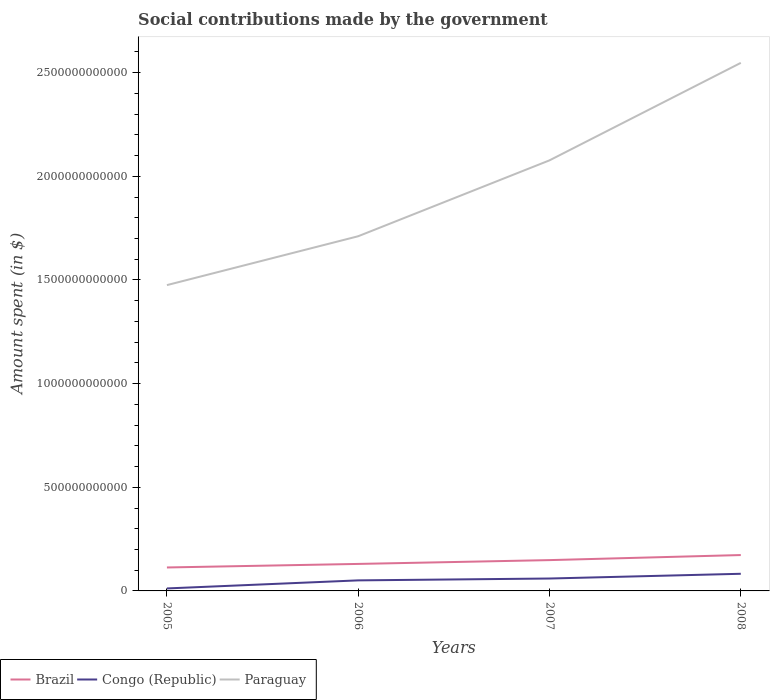Across all years, what is the maximum amount spent on social contributions in Congo (Republic)?
Give a very brief answer. 1.20e+1. What is the total amount spent on social contributions in Congo (Republic) in the graph?
Offer a terse response. -8.97e+09. What is the difference between the highest and the second highest amount spent on social contributions in Brazil?
Provide a short and direct response. 5.99e+1. What is the difference between the highest and the lowest amount spent on social contributions in Brazil?
Your response must be concise. 2. Is the amount spent on social contributions in Congo (Republic) strictly greater than the amount spent on social contributions in Paraguay over the years?
Ensure brevity in your answer.  Yes. How many lines are there?
Provide a succinct answer. 3. What is the difference between two consecutive major ticks on the Y-axis?
Provide a succinct answer. 5.00e+11. Does the graph contain grids?
Ensure brevity in your answer.  No. How many legend labels are there?
Offer a terse response. 3. How are the legend labels stacked?
Offer a very short reply. Horizontal. What is the title of the graph?
Offer a terse response. Social contributions made by the government. What is the label or title of the X-axis?
Make the answer very short. Years. What is the label or title of the Y-axis?
Ensure brevity in your answer.  Amount spent (in $). What is the Amount spent (in $) of Brazil in 2005?
Give a very brief answer. 1.13e+11. What is the Amount spent (in $) in Congo (Republic) in 2005?
Offer a terse response. 1.20e+1. What is the Amount spent (in $) in Paraguay in 2005?
Ensure brevity in your answer.  1.48e+12. What is the Amount spent (in $) of Brazil in 2006?
Ensure brevity in your answer.  1.30e+11. What is the Amount spent (in $) in Congo (Republic) in 2006?
Offer a terse response. 5.09e+1. What is the Amount spent (in $) of Paraguay in 2006?
Ensure brevity in your answer.  1.71e+12. What is the Amount spent (in $) of Brazil in 2007?
Your answer should be compact. 1.49e+11. What is the Amount spent (in $) of Congo (Republic) in 2007?
Keep it short and to the point. 5.99e+1. What is the Amount spent (in $) in Paraguay in 2007?
Give a very brief answer. 2.08e+12. What is the Amount spent (in $) in Brazil in 2008?
Your response must be concise. 1.73e+11. What is the Amount spent (in $) in Congo (Republic) in 2008?
Make the answer very short. 8.27e+1. What is the Amount spent (in $) of Paraguay in 2008?
Offer a very short reply. 2.55e+12. Across all years, what is the maximum Amount spent (in $) in Brazil?
Your answer should be compact. 1.73e+11. Across all years, what is the maximum Amount spent (in $) of Congo (Republic)?
Your response must be concise. 8.27e+1. Across all years, what is the maximum Amount spent (in $) of Paraguay?
Give a very brief answer. 2.55e+12. Across all years, what is the minimum Amount spent (in $) in Brazil?
Make the answer very short. 1.13e+11. Across all years, what is the minimum Amount spent (in $) of Congo (Republic)?
Offer a very short reply. 1.20e+1. Across all years, what is the minimum Amount spent (in $) of Paraguay?
Keep it short and to the point. 1.48e+12. What is the total Amount spent (in $) in Brazil in the graph?
Offer a terse response. 5.65e+11. What is the total Amount spent (in $) of Congo (Republic) in the graph?
Your answer should be compact. 2.05e+11. What is the total Amount spent (in $) in Paraguay in the graph?
Offer a terse response. 7.81e+12. What is the difference between the Amount spent (in $) of Brazil in 2005 and that in 2006?
Provide a short and direct response. -1.71e+1. What is the difference between the Amount spent (in $) in Congo (Republic) in 2005 and that in 2006?
Your response must be concise. -3.89e+1. What is the difference between the Amount spent (in $) of Paraguay in 2005 and that in 2006?
Keep it short and to the point. -2.36e+11. What is the difference between the Amount spent (in $) in Brazil in 2005 and that in 2007?
Keep it short and to the point. -3.55e+1. What is the difference between the Amount spent (in $) of Congo (Republic) in 2005 and that in 2007?
Your answer should be very brief. -4.79e+1. What is the difference between the Amount spent (in $) of Paraguay in 2005 and that in 2007?
Your answer should be very brief. -6.02e+11. What is the difference between the Amount spent (in $) in Brazil in 2005 and that in 2008?
Your response must be concise. -5.99e+1. What is the difference between the Amount spent (in $) in Congo (Republic) in 2005 and that in 2008?
Ensure brevity in your answer.  -7.07e+1. What is the difference between the Amount spent (in $) in Paraguay in 2005 and that in 2008?
Provide a short and direct response. -1.07e+12. What is the difference between the Amount spent (in $) in Brazil in 2006 and that in 2007?
Offer a very short reply. -1.84e+1. What is the difference between the Amount spent (in $) of Congo (Republic) in 2006 and that in 2007?
Your response must be concise. -8.97e+09. What is the difference between the Amount spent (in $) in Paraguay in 2006 and that in 2007?
Provide a succinct answer. -3.66e+11. What is the difference between the Amount spent (in $) of Brazil in 2006 and that in 2008?
Give a very brief answer. -4.28e+1. What is the difference between the Amount spent (in $) in Congo (Republic) in 2006 and that in 2008?
Offer a terse response. -3.18e+1. What is the difference between the Amount spent (in $) of Paraguay in 2006 and that in 2008?
Offer a very short reply. -8.36e+11. What is the difference between the Amount spent (in $) in Brazil in 2007 and that in 2008?
Offer a terse response. -2.44e+1. What is the difference between the Amount spent (in $) of Congo (Republic) in 2007 and that in 2008?
Keep it short and to the point. -2.28e+1. What is the difference between the Amount spent (in $) of Paraguay in 2007 and that in 2008?
Give a very brief answer. -4.70e+11. What is the difference between the Amount spent (in $) in Brazil in 2005 and the Amount spent (in $) in Congo (Republic) in 2006?
Keep it short and to the point. 6.23e+1. What is the difference between the Amount spent (in $) of Brazil in 2005 and the Amount spent (in $) of Paraguay in 2006?
Your answer should be compact. -1.60e+12. What is the difference between the Amount spent (in $) in Congo (Republic) in 2005 and the Amount spent (in $) in Paraguay in 2006?
Your answer should be very brief. -1.70e+12. What is the difference between the Amount spent (in $) of Brazil in 2005 and the Amount spent (in $) of Congo (Republic) in 2007?
Give a very brief answer. 5.33e+1. What is the difference between the Amount spent (in $) in Brazil in 2005 and the Amount spent (in $) in Paraguay in 2007?
Offer a very short reply. -1.96e+12. What is the difference between the Amount spent (in $) of Congo (Republic) in 2005 and the Amount spent (in $) of Paraguay in 2007?
Offer a very short reply. -2.07e+12. What is the difference between the Amount spent (in $) of Brazil in 2005 and the Amount spent (in $) of Congo (Republic) in 2008?
Make the answer very short. 3.04e+1. What is the difference between the Amount spent (in $) of Brazil in 2005 and the Amount spent (in $) of Paraguay in 2008?
Your answer should be very brief. -2.43e+12. What is the difference between the Amount spent (in $) in Congo (Republic) in 2005 and the Amount spent (in $) in Paraguay in 2008?
Offer a terse response. -2.54e+12. What is the difference between the Amount spent (in $) in Brazil in 2006 and the Amount spent (in $) in Congo (Republic) in 2007?
Provide a succinct answer. 7.04e+1. What is the difference between the Amount spent (in $) in Brazil in 2006 and the Amount spent (in $) in Paraguay in 2007?
Your answer should be very brief. -1.95e+12. What is the difference between the Amount spent (in $) of Congo (Republic) in 2006 and the Amount spent (in $) of Paraguay in 2007?
Offer a terse response. -2.03e+12. What is the difference between the Amount spent (in $) in Brazil in 2006 and the Amount spent (in $) in Congo (Republic) in 2008?
Ensure brevity in your answer.  4.76e+1. What is the difference between the Amount spent (in $) in Brazil in 2006 and the Amount spent (in $) in Paraguay in 2008?
Ensure brevity in your answer.  -2.42e+12. What is the difference between the Amount spent (in $) of Congo (Republic) in 2006 and the Amount spent (in $) of Paraguay in 2008?
Provide a succinct answer. -2.50e+12. What is the difference between the Amount spent (in $) in Brazil in 2007 and the Amount spent (in $) in Congo (Republic) in 2008?
Your response must be concise. 6.59e+1. What is the difference between the Amount spent (in $) of Brazil in 2007 and the Amount spent (in $) of Paraguay in 2008?
Offer a very short reply. -2.40e+12. What is the difference between the Amount spent (in $) of Congo (Republic) in 2007 and the Amount spent (in $) of Paraguay in 2008?
Your answer should be very brief. -2.49e+12. What is the average Amount spent (in $) of Brazil per year?
Offer a very short reply. 1.41e+11. What is the average Amount spent (in $) of Congo (Republic) per year?
Keep it short and to the point. 5.14e+1. What is the average Amount spent (in $) of Paraguay per year?
Your answer should be compact. 1.95e+12. In the year 2005, what is the difference between the Amount spent (in $) of Brazil and Amount spent (in $) of Congo (Republic)?
Give a very brief answer. 1.01e+11. In the year 2005, what is the difference between the Amount spent (in $) of Brazil and Amount spent (in $) of Paraguay?
Offer a terse response. -1.36e+12. In the year 2005, what is the difference between the Amount spent (in $) in Congo (Republic) and Amount spent (in $) in Paraguay?
Provide a succinct answer. -1.46e+12. In the year 2006, what is the difference between the Amount spent (in $) of Brazil and Amount spent (in $) of Congo (Republic)?
Offer a very short reply. 7.94e+1. In the year 2006, what is the difference between the Amount spent (in $) of Brazil and Amount spent (in $) of Paraguay?
Your answer should be compact. -1.58e+12. In the year 2006, what is the difference between the Amount spent (in $) in Congo (Republic) and Amount spent (in $) in Paraguay?
Your answer should be compact. -1.66e+12. In the year 2007, what is the difference between the Amount spent (in $) of Brazil and Amount spent (in $) of Congo (Republic)?
Give a very brief answer. 8.88e+1. In the year 2007, what is the difference between the Amount spent (in $) of Brazil and Amount spent (in $) of Paraguay?
Make the answer very short. -1.93e+12. In the year 2007, what is the difference between the Amount spent (in $) of Congo (Republic) and Amount spent (in $) of Paraguay?
Your answer should be very brief. -2.02e+12. In the year 2008, what is the difference between the Amount spent (in $) in Brazil and Amount spent (in $) in Congo (Republic)?
Keep it short and to the point. 9.03e+1. In the year 2008, what is the difference between the Amount spent (in $) in Brazil and Amount spent (in $) in Paraguay?
Provide a succinct answer. -2.37e+12. In the year 2008, what is the difference between the Amount spent (in $) in Congo (Republic) and Amount spent (in $) in Paraguay?
Your answer should be very brief. -2.46e+12. What is the ratio of the Amount spent (in $) of Brazil in 2005 to that in 2006?
Provide a succinct answer. 0.87. What is the ratio of the Amount spent (in $) of Congo (Republic) in 2005 to that in 2006?
Make the answer very short. 0.24. What is the ratio of the Amount spent (in $) in Paraguay in 2005 to that in 2006?
Provide a short and direct response. 0.86. What is the ratio of the Amount spent (in $) in Brazil in 2005 to that in 2007?
Offer a very short reply. 0.76. What is the ratio of the Amount spent (in $) of Congo (Republic) in 2005 to that in 2007?
Offer a very short reply. 0.2. What is the ratio of the Amount spent (in $) in Paraguay in 2005 to that in 2007?
Your answer should be very brief. 0.71. What is the ratio of the Amount spent (in $) of Brazil in 2005 to that in 2008?
Provide a short and direct response. 0.65. What is the ratio of the Amount spent (in $) in Congo (Republic) in 2005 to that in 2008?
Provide a short and direct response. 0.14. What is the ratio of the Amount spent (in $) in Paraguay in 2005 to that in 2008?
Keep it short and to the point. 0.58. What is the ratio of the Amount spent (in $) of Brazil in 2006 to that in 2007?
Provide a short and direct response. 0.88. What is the ratio of the Amount spent (in $) of Congo (Republic) in 2006 to that in 2007?
Offer a very short reply. 0.85. What is the ratio of the Amount spent (in $) of Paraguay in 2006 to that in 2007?
Your response must be concise. 0.82. What is the ratio of the Amount spent (in $) in Brazil in 2006 to that in 2008?
Keep it short and to the point. 0.75. What is the ratio of the Amount spent (in $) of Congo (Republic) in 2006 to that in 2008?
Offer a terse response. 0.62. What is the ratio of the Amount spent (in $) in Paraguay in 2006 to that in 2008?
Your answer should be compact. 0.67. What is the ratio of the Amount spent (in $) in Brazil in 2007 to that in 2008?
Provide a succinct answer. 0.86. What is the ratio of the Amount spent (in $) of Congo (Republic) in 2007 to that in 2008?
Your answer should be very brief. 0.72. What is the ratio of the Amount spent (in $) of Paraguay in 2007 to that in 2008?
Provide a short and direct response. 0.82. What is the difference between the highest and the second highest Amount spent (in $) in Brazil?
Offer a terse response. 2.44e+1. What is the difference between the highest and the second highest Amount spent (in $) in Congo (Republic)?
Provide a succinct answer. 2.28e+1. What is the difference between the highest and the second highest Amount spent (in $) of Paraguay?
Ensure brevity in your answer.  4.70e+11. What is the difference between the highest and the lowest Amount spent (in $) in Brazil?
Ensure brevity in your answer.  5.99e+1. What is the difference between the highest and the lowest Amount spent (in $) of Congo (Republic)?
Provide a short and direct response. 7.07e+1. What is the difference between the highest and the lowest Amount spent (in $) of Paraguay?
Your answer should be very brief. 1.07e+12. 